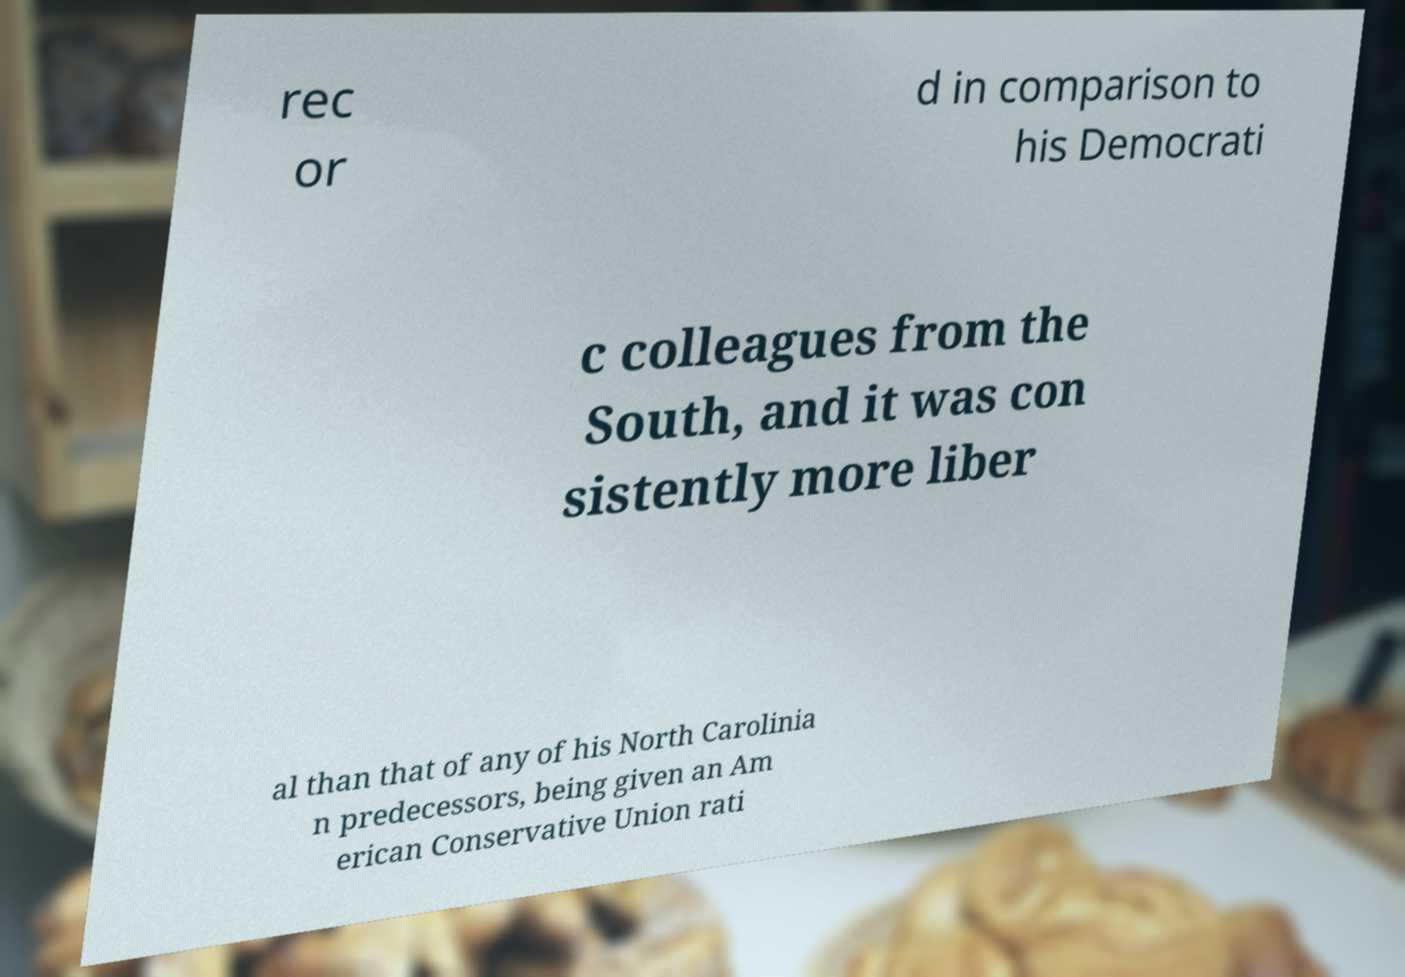What messages or text are displayed in this image? I need them in a readable, typed format. rec or d in comparison to his Democrati c colleagues from the South, and it was con sistently more liber al than that of any of his North Carolinia n predecessors, being given an Am erican Conservative Union rati 